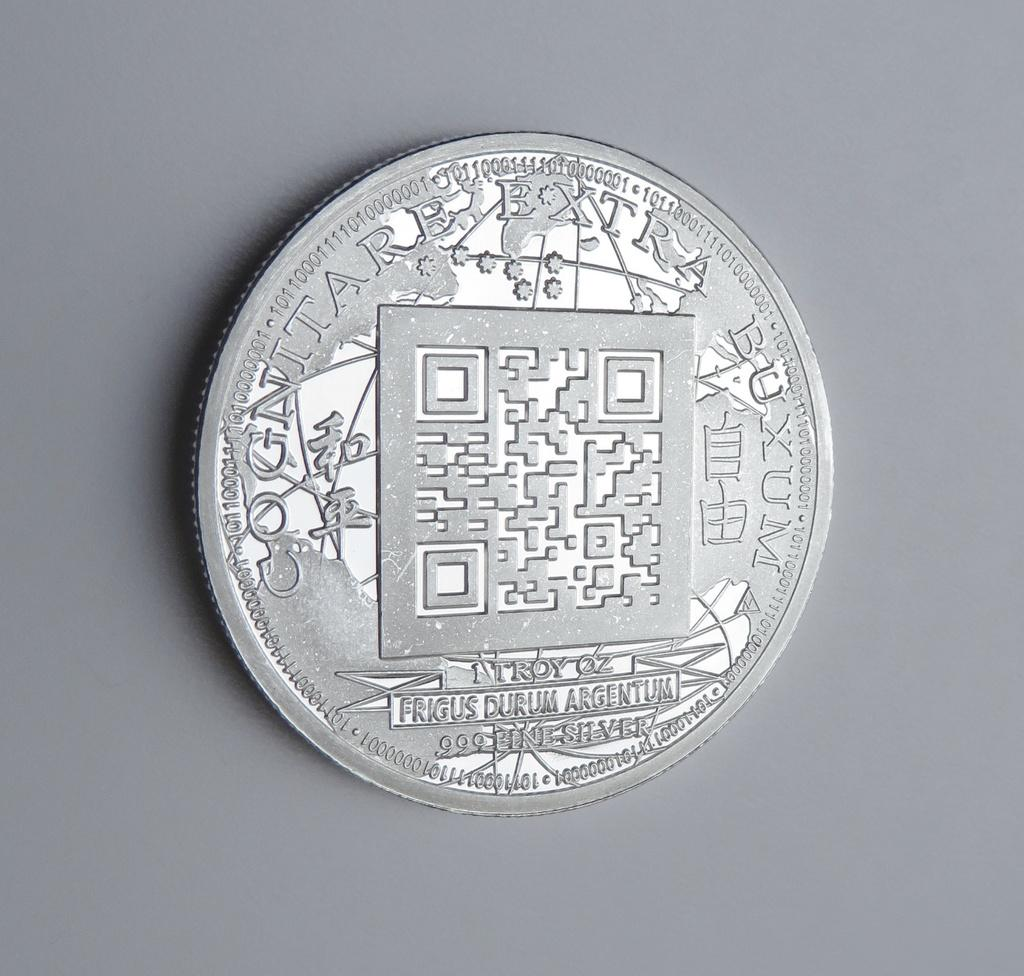<image>
Give a short and clear explanation of the subsequent image. Silver coin with words that say "Frigus Durum Argentum". 